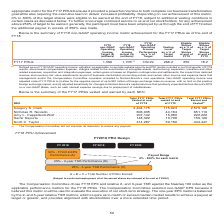According to Nortonlifelock's financial document, Were any payouts reduced by the Compensation Committee? The Compensation Committee did not exercise its discretion to reduce any payouts. The document states: "(1) The Compensation Committee did not exercise its discretion to reduce any payouts...." Also, What does the table show? summary of the FY17 PRUs vested and earned by each NEO. The document states: "Below is the summary of the FY17 PRUs vested and earned by each NEO...." Also, What is the Total FY17 PRUs Earned and Vested for  Gregory S. Clark? According to the financial document, 2,579,198. The relevant text states: "Gregory S. Clark . 2,404,175 175,023 2,579,198 Nicholas R. Noviello . 606,935 44,184 651,119 Amy L. Cappellanti-Wolf . 207,142 15,080 222,222 Sami..." Also, can you calculate: What is the difference between Total FY17 PRUs Earned and Vested between Gregory S. Clark and  Nicholas R. Noviello? Based on the calculation: 2,579,198-651,119, the result is 1928079. This is based on the information: "3 2,579,198 Nicholas R. Noviello . 606,935 44,184 651,119 Amy L. Cappellanti-Wolf . 207,142 15,080 222,222 Samir Kapuria . 148,322 10,798 159,120 Scott C. Ta Gregory S. Clark . 2,404,175 175,023 2,579..." The key data points involved are: 2,579,198, 651,119. Also, can you calculate: What is the total Total FY17 PRUs Earned and Vested for all NEOs? Based on the calculation: 2,579,198+651,119+222,222+159,120+444,447, the result is 4056106. This is based on the information: "3 2,579,198 Nicholas R. Noviello . 606,935 44,184 651,119 Amy L. Cappellanti-Wolf . 207,142 15,080 222,222 Samir Kapuria . 148,322 10,798 159,120 Scott C. Ta 651,119 Amy L. Cappellanti-Wolf . 207,142 ..." The key data points involved are: 159,120, 2,579,198, 222,222. Also, can you calculate: What is the average Total FY17 PRUs Earned and Vested for all NEOs? To answer this question, I need to perform calculations using the financial data. The calculation is: (2,579,198+651,119+222,222+159,120+444,447)/5, which equals 811221.2. This is based on the information: "3 2,579,198 Nicholas R. Noviello . 606,935 44,184 651,119 Amy L. Cappellanti-Wolf . 207,142 15,080 222,222 Samir Kapuria . 148,322 10,798 159,120 Scott C. Ta 651,119 Amy L. Cappellanti-Wolf . 207,142 ..." The key data points involved are: 159,120, 2,579,198, 222,222. 